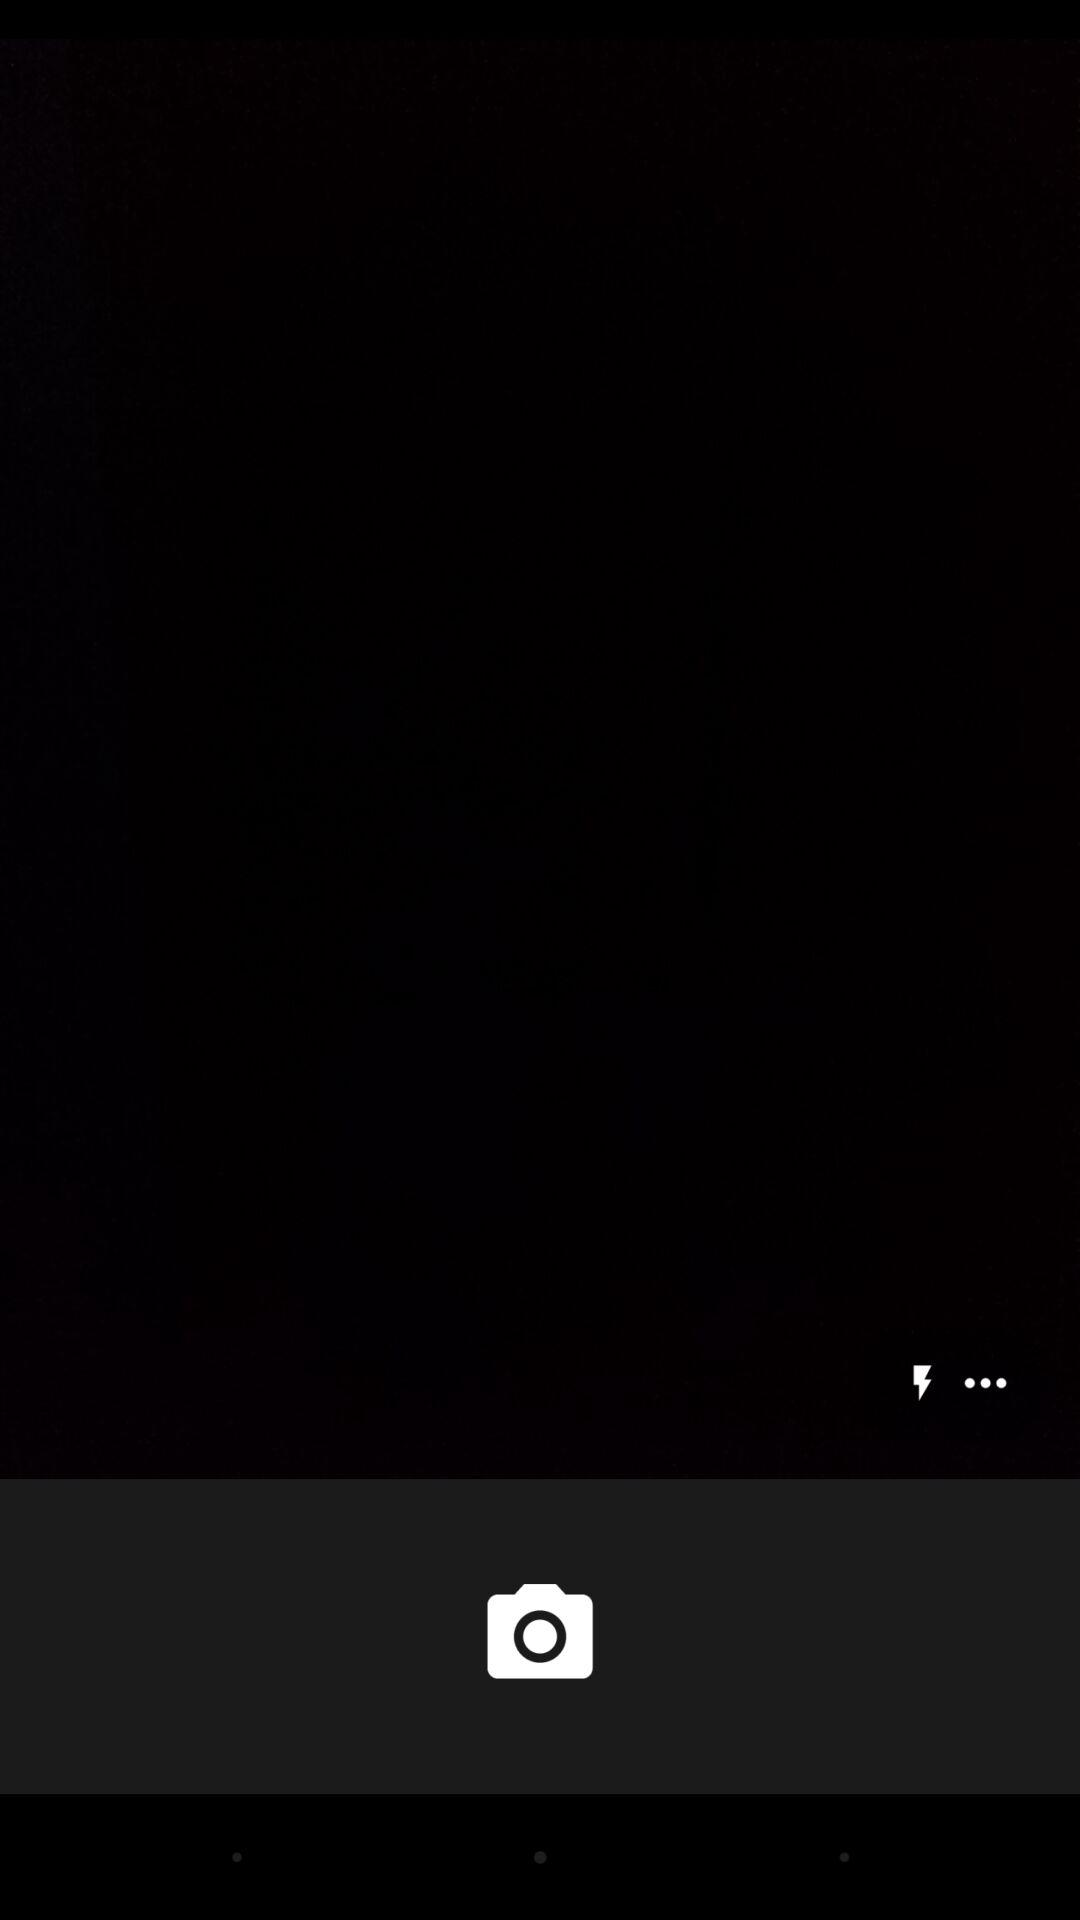How many more dots are there than lightning bolts?
Answer the question using a single word or phrase. 2 